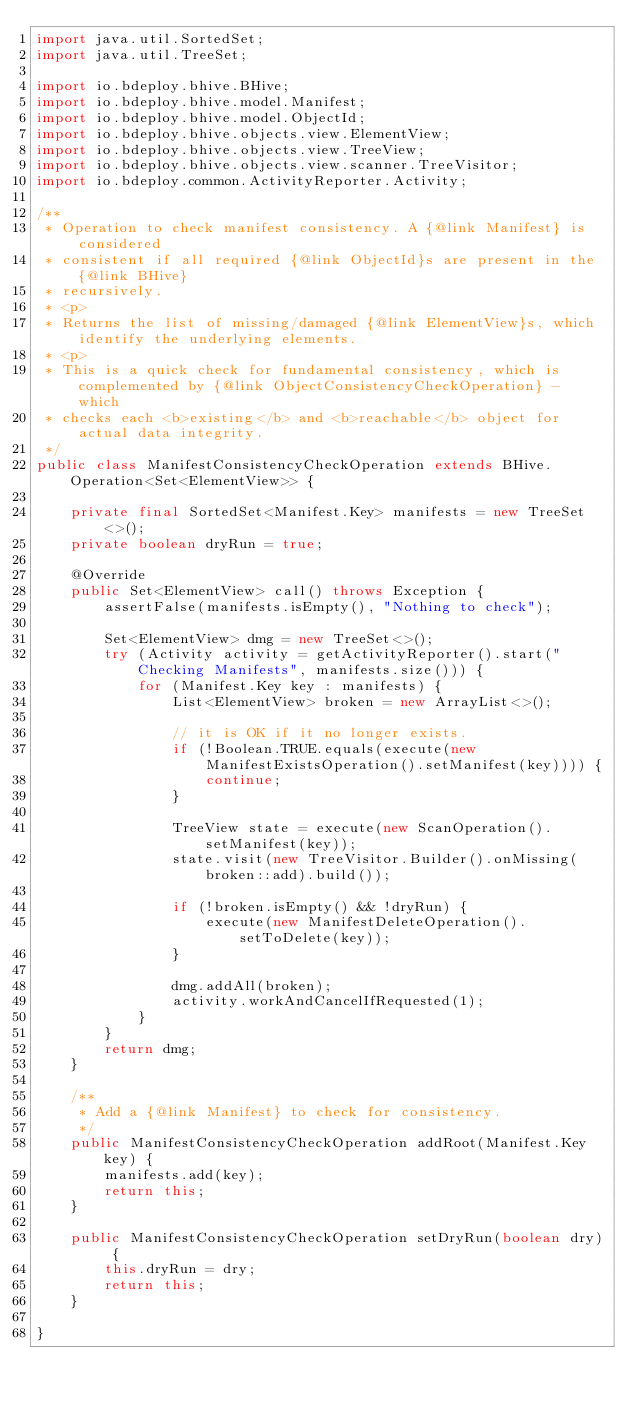Convert code to text. <code><loc_0><loc_0><loc_500><loc_500><_Java_>import java.util.SortedSet;
import java.util.TreeSet;

import io.bdeploy.bhive.BHive;
import io.bdeploy.bhive.model.Manifest;
import io.bdeploy.bhive.model.ObjectId;
import io.bdeploy.bhive.objects.view.ElementView;
import io.bdeploy.bhive.objects.view.TreeView;
import io.bdeploy.bhive.objects.view.scanner.TreeVisitor;
import io.bdeploy.common.ActivityReporter.Activity;

/**
 * Operation to check manifest consistency. A {@link Manifest} is considered
 * consistent if all required {@link ObjectId}s are present in the {@link BHive}
 * recursively.
 * <p>
 * Returns the list of missing/damaged {@link ElementView}s, which identify the underlying elements.
 * <p>
 * This is a quick check for fundamental consistency, which is complemented by {@link ObjectConsistencyCheckOperation} - which
 * checks each <b>existing</b> and <b>reachable</b> object for actual data integrity.
 */
public class ManifestConsistencyCheckOperation extends BHive.Operation<Set<ElementView>> {

    private final SortedSet<Manifest.Key> manifests = new TreeSet<>();
    private boolean dryRun = true;

    @Override
    public Set<ElementView> call() throws Exception {
        assertFalse(manifests.isEmpty(), "Nothing to check");

        Set<ElementView> dmg = new TreeSet<>();
        try (Activity activity = getActivityReporter().start("Checking Manifests", manifests.size())) {
            for (Manifest.Key key : manifests) {
                List<ElementView> broken = new ArrayList<>();

                // it is OK if it no longer exists.
                if (!Boolean.TRUE.equals(execute(new ManifestExistsOperation().setManifest(key)))) {
                    continue;
                }

                TreeView state = execute(new ScanOperation().setManifest(key));
                state.visit(new TreeVisitor.Builder().onMissing(broken::add).build());

                if (!broken.isEmpty() && !dryRun) {
                    execute(new ManifestDeleteOperation().setToDelete(key));
                }

                dmg.addAll(broken);
                activity.workAndCancelIfRequested(1);
            }
        }
        return dmg;
    }

    /**
     * Add a {@link Manifest} to check for consistency.
     */
    public ManifestConsistencyCheckOperation addRoot(Manifest.Key key) {
        manifests.add(key);
        return this;
    }

    public ManifestConsistencyCheckOperation setDryRun(boolean dry) {
        this.dryRun = dry;
        return this;
    }

}
</code> 